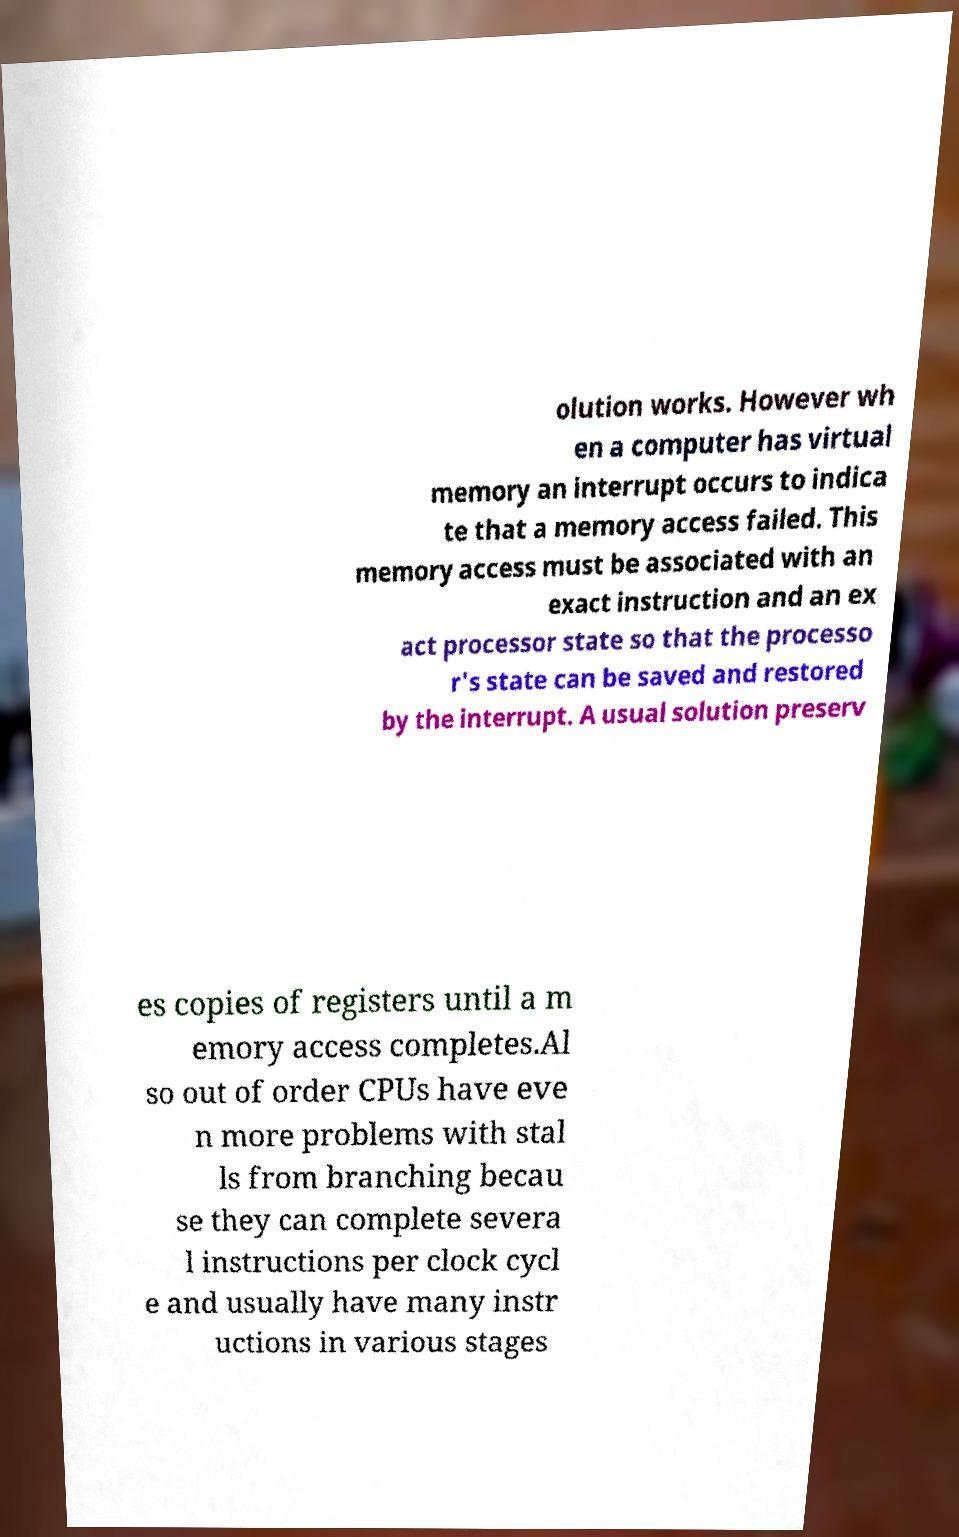I need the written content from this picture converted into text. Can you do that? olution works. However wh en a computer has virtual memory an interrupt occurs to indica te that a memory access failed. This memory access must be associated with an exact instruction and an ex act processor state so that the processo r's state can be saved and restored by the interrupt. A usual solution preserv es copies of registers until a m emory access completes.Al so out of order CPUs have eve n more problems with stal ls from branching becau se they can complete severa l instructions per clock cycl e and usually have many instr uctions in various stages 